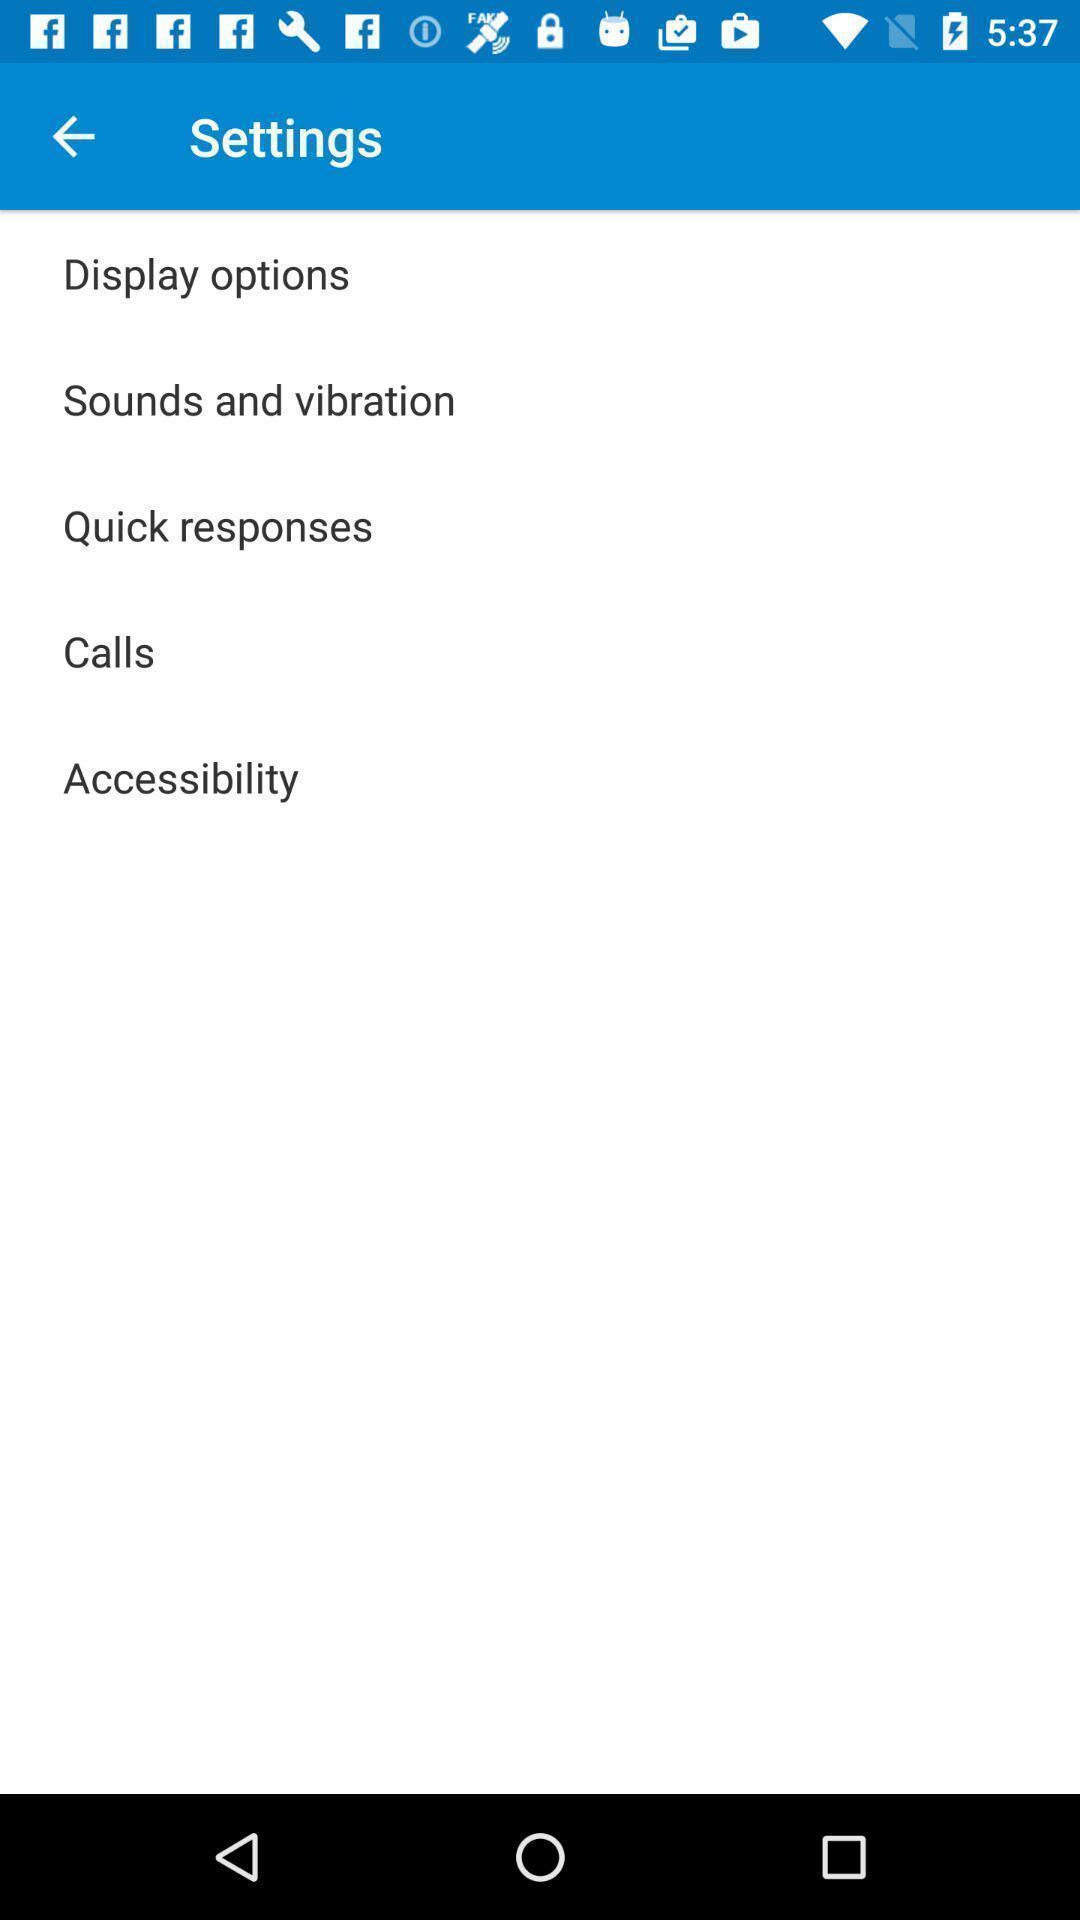Summarize the information in this screenshot. Settings page displayed. 